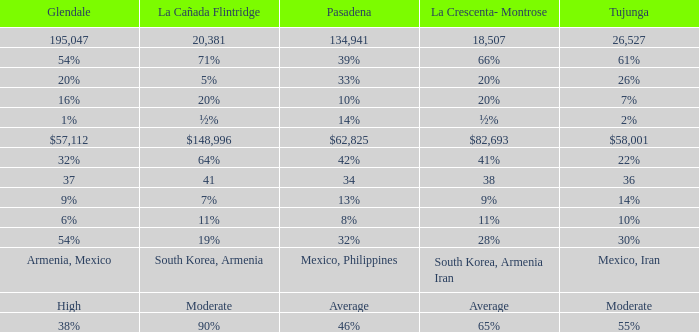What is the percentage of Glendale when La Canada Flintridge is 5%? 20%. 